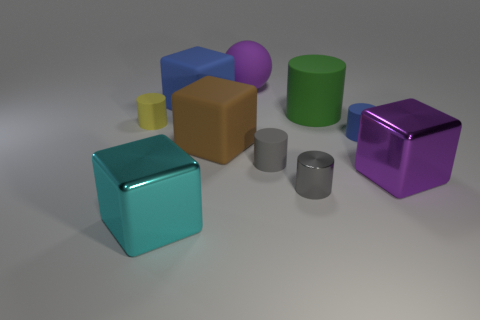Are there any objects that share the same color but differ in shape? Yes, the purple objects vary in shape; one is a sphere and the other is a cube. 